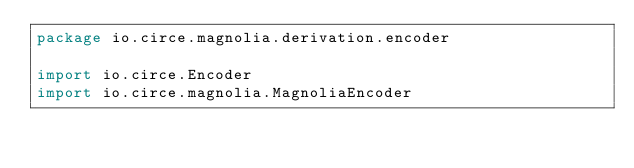Convert code to text. <code><loc_0><loc_0><loc_500><loc_500><_Scala_>package io.circe.magnolia.derivation.encoder

import io.circe.Encoder
import io.circe.magnolia.MagnoliaEncoder</code> 